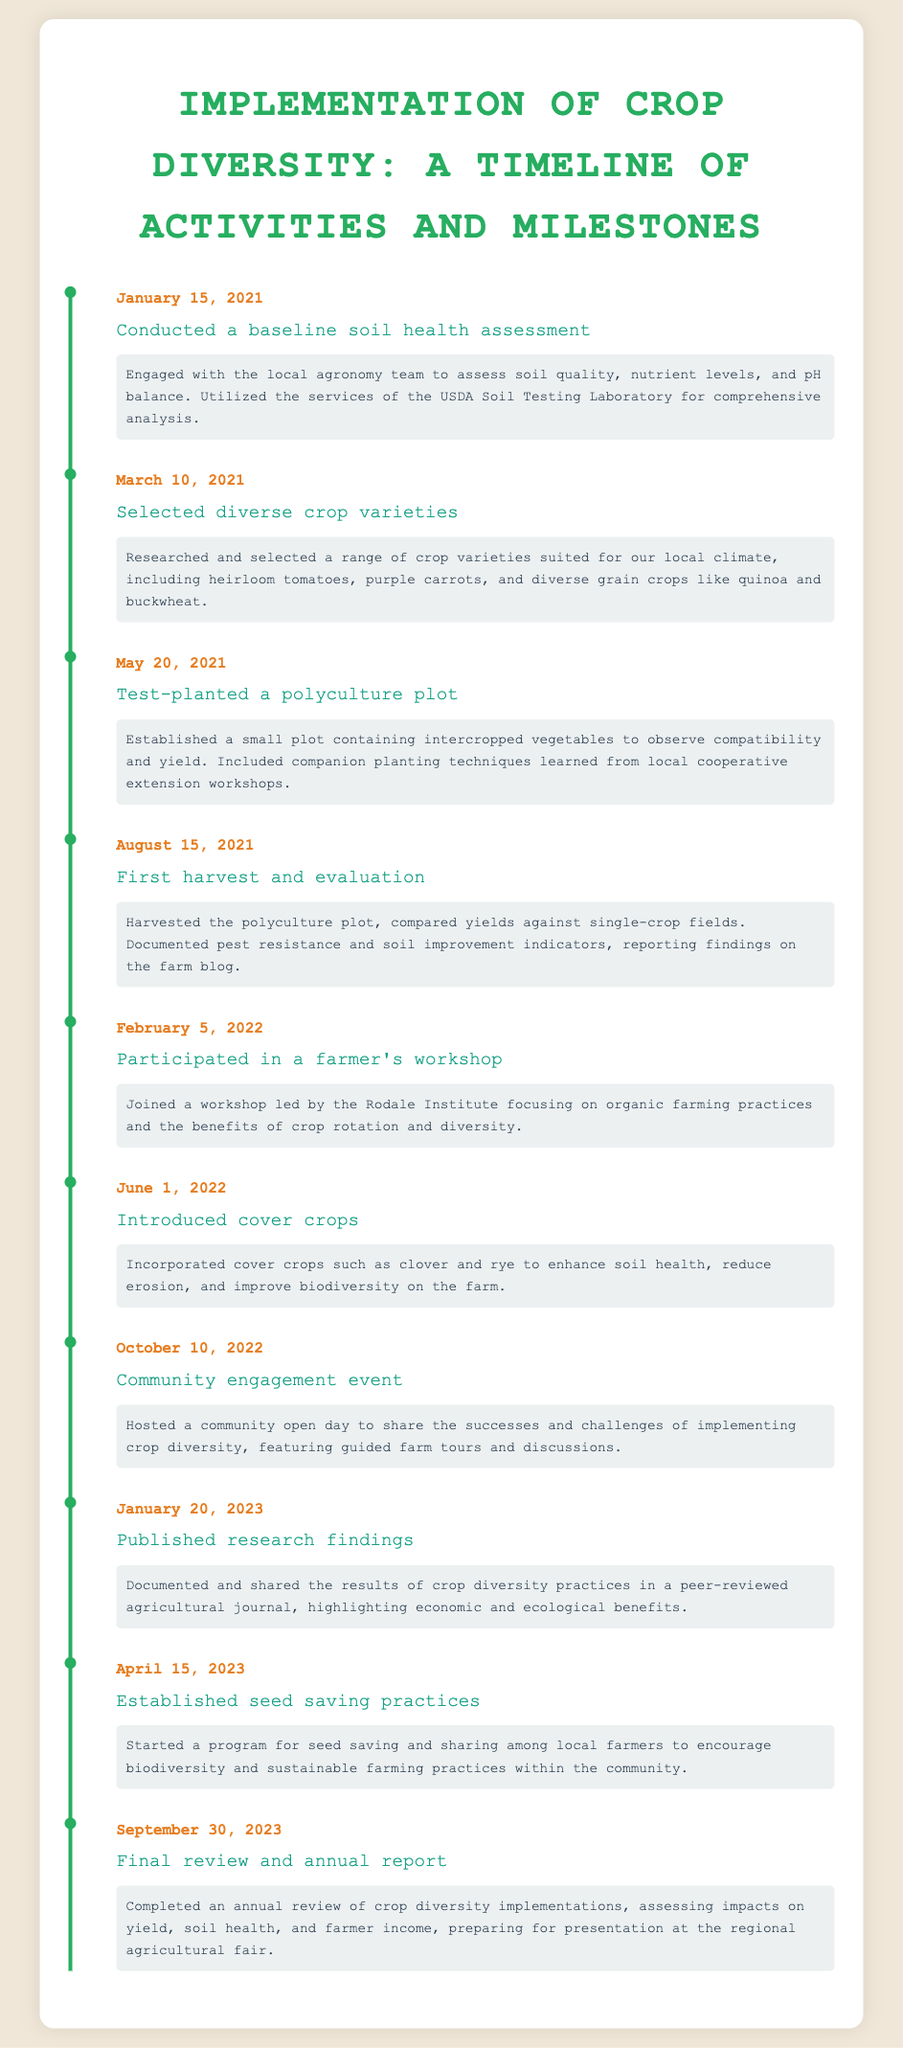What date was the baseline soil health assessment conducted? The date of the baseline soil health assessment is specifically mentioned in the timeline.
Answer: January 15, 2021 What crop variety was selected on March 10, 2021? The selected crop varieties are described in terms of their diversity and suitability for the local climate.
Answer: Heirloom tomatoes What activity took place on August 15, 2021? This date corresponds to a specific milestone related to the harvest and evaluation phase of the crop diversity implementation.
Answer: First harvest and evaluation How many days after the test-planting was the first harvest conducted? It is necessary to calculate the days between the test-planting and the harvest dates listed in the timeline.
Answer: 87 days Which cover crops were introduced on June 1, 2022? The document mentions specific cover crops that were used to enhance soil health and biodiversity.
Answer: Clover and rye What was the purpose of the community engagement event on October 10, 2022? The description outlines the significance of the community engagement event for sharing experiences.
Answer: Share successes and challenges What research findings were published on January 20, 2023? This particular event describes the documentation and sharing of research findings related to crop diversity.
Answer: Economic and ecological benefits What outcome was assessed in the final review on September 30, 2023? The final review assesses specific outcomes regarding crop diversity implementation.
Answer: Yield, soil health, and farmer income 